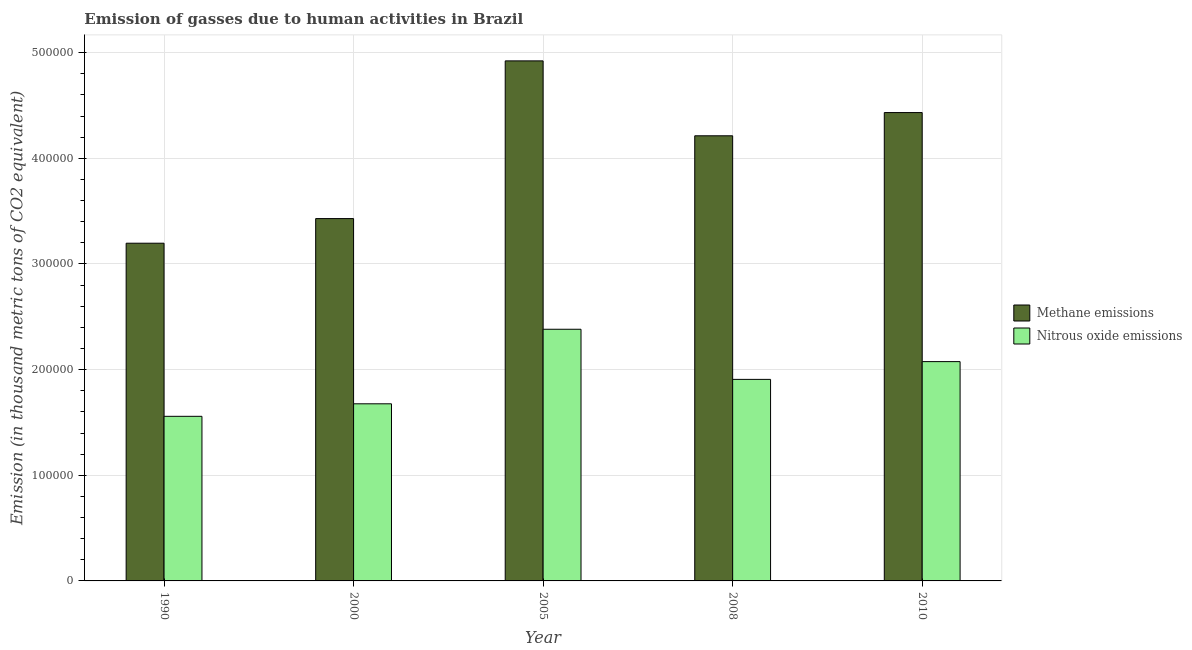How many groups of bars are there?
Your answer should be compact. 5. Are the number of bars per tick equal to the number of legend labels?
Your answer should be very brief. Yes. Are the number of bars on each tick of the X-axis equal?
Your answer should be compact. Yes. What is the amount of nitrous oxide emissions in 2005?
Your response must be concise. 2.38e+05. Across all years, what is the maximum amount of methane emissions?
Give a very brief answer. 4.92e+05. Across all years, what is the minimum amount of nitrous oxide emissions?
Your answer should be compact. 1.56e+05. In which year was the amount of methane emissions minimum?
Give a very brief answer. 1990. What is the total amount of methane emissions in the graph?
Your response must be concise. 2.02e+06. What is the difference between the amount of nitrous oxide emissions in 1990 and that in 2000?
Your answer should be very brief. -1.19e+04. What is the difference between the amount of methane emissions in 1990 and the amount of nitrous oxide emissions in 2010?
Your response must be concise. -1.24e+05. What is the average amount of nitrous oxide emissions per year?
Your response must be concise. 1.92e+05. In the year 2000, what is the difference between the amount of methane emissions and amount of nitrous oxide emissions?
Your response must be concise. 0. What is the ratio of the amount of methane emissions in 2005 to that in 2008?
Make the answer very short. 1.17. Is the amount of methane emissions in 2000 less than that in 2008?
Ensure brevity in your answer.  Yes. What is the difference between the highest and the second highest amount of nitrous oxide emissions?
Provide a succinct answer. 3.06e+04. What is the difference between the highest and the lowest amount of nitrous oxide emissions?
Offer a terse response. 8.24e+04. In how many years, is the amount of methane emissions greater than the average amount of methane emissions taken over all years?
Offer a terse response. 3. Is the sum of the amount of methane emissions in 2000 and 2010 greater than the maximum amount of nitrous oxide emissions across all years?
Ensure brevity in your answer.  Yes. What does the 2nd bar from the left in 1990 represents?
Your answer should be compact. Nitrous oxide emissions. What does the 2nd bar from the right in 2010 represents?
Keep it short and to the point. Methane emissions. Where does the legend appear in the graph?
Your answer should be very brief. Center right. How many legend labels are there?
Your response must be concise. 2. What is the title of the graph?
Offer a very short reply. Emission of gasses due to human activities in Brazil. Does "Net National savings" appear as one of the legend labels in the graph?
Give a very brief answer. No. What is the label or title of the X-axis?
Keep it short and to the point. Year. What is the label or title of the Y-axis?
Ensure brevity in your answer.  Emission (in thousand metric tons of CO2 equivalent). What is the Emission (in thousand metric tons of CO2 equivalent) in Methane emissions in 1990?
Keep it short and to the point. 3.20e+05. What is the Emission (in thousand metric tons of CO2 equivalent) in Nitrous oxide emissions in 1990?
Provide a short and direct response. 1.56e+05. What is the Emission (in thousand metric tons of CO2 equivalent) of Methane emissions in 2000?
Ensure brevity in your answer.  3.43e+05. What is the Emission (in thousand metric tons of CO2 equivalent) in Nitrous oxide emissions in 2000?
Provide a succinct answer. 1.68e+05. What is the Emission (in thousand metric tons of CO2 equivalent) of Methane emissions in 2005?
Your answer should be very brief. 4.92e+05. What is the Emission (in thousand metric tons of CO2 equivalent) of Nitrous oxide emissions in 2005?
Provide a succinct answer. 2.38e+05. What is the Emission (in thousand metric tons of CO2 equivalent) of Methane emissions in 2008?
Give a very brief answer. 4.21e+05. What is the Emission (in thousand metric tons of CO2 equivalent) in Nitrous oxide emissions in 2008?
Your response must be concise. 1.91e+05. What is the Emission (in thousand metric tons of CO2 equivalent) of Methane emissions in 2010?
Your answer should be very brief. 4.43e+05. What is the Emission (in thousand metric tons of CO2 equivalent) of Nitrous oxide emissions in 2010?
Keep it short and to the point. 2.08e+05. Across all years, what is the maximum Emission (in thousand metric tons of CO2 equivalent) of Methane emissions?
Offer a very short reply. 4.92e+05. Across all years, what is the maximum Emission (in thousand metric tons of CO2 equivalent) of Nitrous oxide emissions?
Ensure brevity in your answer.  2.38e+05. Across all years, what is the minimum Emission (in thousand metric tons of CO2 equivalent) of Methane emissions?
Your answer should be very brief. 3.20e+05. Across all years, what is the minimum Emission (in thousand metric tons of CO2 equivalent) in Nitrous oxide emissions?
Ensure brevity in your answer.  1.56e+05. What is the total Emission (in thousand metric tons of CO2 equivalent) of Methane emissions in the graph?
Ensure brevity in your answer.  2.02e+06. What is the total Emission (in thousand metric tons of CO2 equivalent) in Nitrous oxide emissions in the graph?
Offer a very short reply. 9.60e+05. What is the difference between the Emission (in thousand metric tons of CO2 equivalent) in Methane emissions in 1990 and that in 2000?
Make the answer very short. -2.33e+04. What is the difference between the Emission (in thousand metric tons of CO2 equivalent) of Nitrous oxide emissions in 1990 and that in 2000?
Your answer should be very brief. -1.19e+04. What is the difference between the Emission (in thousand metric tons of CO2 equivalent) of Methane emissions in 1990 and that in 2005?
Provide a succinct answer. -1.73e+05. What is the difference between the Emission (in thousand metric tons of CO2 equivalent) of Nitrous oxide emissions in 1990 and that in 2005?
Your response must be concise. -8.24e+04. What is the difference between the Emission (in thousand metric tons of CO2 equivalent) of Methane emissions in 1990 and that in 2008?
Ensure brevity in your answer.  -1.02e+05. What is the difference between the Emission (in thousand metric tons of CO2 equivalent) of Nitrous oxide emissions in 1990 and that in 2008?
Make the answer very short. -3.50e+04. What is the difference between the Emission (in thousand metric tons of CO2 equivalent) in Methane emissions in 1990 and that in 2010?
Your answer should be compact. -1.24e+05. What is the difference between the Emission (in thousand metric tons of CO2 equivalent) of Nitrous oxide emissions in 1990 and that in 2010?
Offer a very short reply. -5.18e+04. What is the difference between the Emission (in thousand metric tons of CO2 equivalent) of Methane emissions in 2000 and that in 2005?
Provide a succinct answer. -1.49e+05. What is the difference between the Emission (in thousand metric tons of CO2 equivalent) in Nitrous oxide emissions in 2000 and that in 2005?
Ensure brevity in your answer.  -7.06e+04. What is the difference between the Emission (in thousand metric tons of CO2 equivalent) of Methane emissions in 2000 and that in 2008?
Offer a terse response. -7.84e+04. What is the difference between the Emission (in thousand metric tons of CO2 equivalent) in Nitrous oxide emissions in 2000 and that in 2008?
Provide a short and direct response. -2.31e+04. What is the difference between the Emission (in thousand metric tons of CO2 equivalent) in Methane emissions in 2000 and that in 2010?
Offer a terse response. -1.00e+05. What is the difference between the Emission (in thousand metric tons of CO2 equivalent) of Nitrous oxide emissions in 2000 and that in 2010?
Ensure brevity in your answer.  -3.99e+04. What is the difference between the Emission (in thousand metric tons of CO2 equivalent) in Methane emissions in 2005 and that in 2008?
Your response must be concise. 7.09e+04. What is the difference between the Emission (in thousand metric tons of CO2 equivalent) of Nitrous oxide emissions in 2005 and that in 2008?
Offer a very short reply. 4.74e+04. What is the difference between the Emission (in thousand metric tons of CO2 equivalent) in Methane emissions in 2005 and that in 2010?
Give a very brief answer. 4.89e+04. What is the difference between the Emission (in thousand metric tons of CO2 equivalent) in Nitrous oxide emissions in 2005 and that in 2010?
Give a very brief answer. 3.06e+04. What is the difference between the Emission (in thousand metric tons of CO2 equivalent) in Methane emissions in 2008 and that in 2010?
Provide a short and direct response. -2.20e+04. What is the difference between the Emission (in thousand metric tons of CO2 equivalent) in Nitrous oxide emissions in 2008 and that in 2010?
Provide a succinct answer. -1.68e+04. What is the difference between the Emission (in thousand metric tons of CO2 equivalent) in Methane emissions in 1990 and the Emission (in thousand metric tons of CO2 equivalent) in Nitrous oxide emissions in 2000?
Offer a very short reply. 1.52e+05. What is the difference between the Emission (in thousand metric tons of CO2 equivalent) of Methane emissions in 1990 and the Emission (in thousand metric tons of CO2 equivalent) of Nitrous oxide emissions in 2005?
Give a very brief answer. 8.14e+04. What is the difference between the Emission (in thousand metric tons of CO2 equivalent) of Methane emissions in 1990 and the Emission (in thousand metric tons of CO2 equivalent) of Nitrous oxide emissions in 2008?
Provide a succinct answer. 1.29e+05. What is the difference between the Emission (in thousand metric tons of CO2 equivalent) of Methane emissions in 1990 and the Emission (in thousand metric tons of CO2 equivalent) of Nitrous oxide emissions in 2010?
Provide a short and direct response. 1.12e+05. What is the difference between the Emission (in thousand metric tons of CO2 equivalent) in Methane emissions in 2000 and the Emission (in thousand metric tons of CO2 equivalent) in Nitrous oxide emissions in 2005?
Provide a short and direct response. 1.05e+05. What is the difference between the Emission (in thousand metric tons of CO2 equivalent) in Methane emissions in 2000 and the Emission (in thousand metric tons of CO2 equivalent) in Nitrous oxide emissions in 2008?
Keep it short and to the point. 1.52e+05. What is the difference between the Emission (in thousand metric tons of CO2 equivalent) in Methane emissions in 2000 and the Emission (in thousand metric tons of CO2 equivalent) in Nitrous oxide emissions in 2010?
Provide a succinct answer. 1.35e+05. What is the difference between the Emission (in thousand metric tons of CO2 equivalent) of Methane emissions in 2005 and the Emission (in thousand metric tons of CO2 equivalent) of Nitrous oxide emissions in 2008?
Ensure brevity in your answer.  3.01e+05. What is the difference between the Emission (in thousand metric tons of CO2 equivalent) of Methane emissions in 2005 and the Emission (in thousand metric tons of CO2 equivalent) of Nitrous oxide emissions in 2010?
Your answer should be very brief. 2.85e+05. What is the difference between the Emission (in thousand metric tons of CO2 equivalent) of Methane emissions in 2008 and the Emission (in thousand metric tons of CO2 equivalent) of Nitrous oxide emissions in 2010?
Your response must be concise. 2.14e+05. What is the average Emission (in thousand metric tons of CO2 equivalent) in Methane emissions per year?
Your response must be concise. 4.04e+05. What is the average Emission (in thousand metric tons of CO2 equivalent) in Nitrous oxide emissions per year?
Offer a very short reply. 1.92e+05. In the year 1990, what is the difference between the Emission (in thousand metric tons of CO2 equivalent) in Methane emissions and Emission (in thousand metric tons of CO2 equivalent) in Nitrous oxide emissions?
Your answer should be compact. 1.64e+05. In the year 2000, what is the difference between the Emission (in thousand metric tons of CO2 equivalent) in Methane emissions and Emission (in thousand metric tons of CO2 equivalent) in Nitrous oxide emissions?
Make the answer very short. 1.75e+05. In the year 2005, what is the difference between the Emission (in thousand metric tons of CO2 equivalent) of Methane emissions and Emission (in thousand metric tons of CO2 equivalent) of Nitrous oxide emissions?
Your response must be concise. 2.54e+05. In the year 2008, what is the difference between the Emission (in thousand metric tons of CO2 equivalent) in Methane emissions and Emission (in thousand metric tons of CO2 equivalent) in Nitrous oxide emissions?
Offer a very short reply. 2.31e+05. In the year 2010, what is the difference between the Emission (in thousand metric tons of CO2 equivalent) of Methane emissions and Emission (in thousand metric tons of CO2 equivalent) of Nitrous oxide emissions?
Your response must be concise. 2.36e+05. What is the ratio of the Emission (in thousand metric tons of CO2 equivalent) of Methane emissions in 1990 to that in 2000?
Provide a succinct answer. 0.93. What is the ratio of the Emission (in thousand metric tons of CO2 equivalent) in Nitrous oxide emissions in 1990 to that in 2000?
Offer a very short reply. 0.93. What is the ratio of the Emission (in thousand metric tons of CO2 equivalent) of Methane emissions in 1990 to that in 2005?
Your answer should be very brief. 0.65. What is the ratio of the Emission (in thousand metric tons of CO2 equivalent) of Nitrous oxide emissions in 1990 to that in 2005?
Provide a short and direct response. 0.65. What is the ratio of the Emission (in thousand metric tons of CO2 equivalent) in Methane emissions in 1990 to that in 2008?
Provide a short and direct response. 0.76. What is the ratio of the Emission (in thousand metric tons of CO2 equivalent) in Nitrous oxide emissions in 1990 to that in 2008?
Your answer should be compact. 0.82. What is the ratio of the Emission (in thousand metric tons of CO2 equivalent) in Methane emissions in 1990 to that in 2010?
Provide a short and direct response. 0.72. What is the ratio of the Emission (in thousand metric tons of CO2 equivalent) of Nitrous oxide emissions in 1990 to that in 2010?
Provide a succinct answer. 0.75. What is the ratio of the Emission (in thousand metric tons of CO2 equivalent) of Methane emissions in 2000 to that in 2005?
Ensure brevity in your answer.  0.7. What is the ratio of the Emission (in thousand metric tons of CO2 equivalent) in Nitrous oxide emissions in 2000 to that in 2005?
Your response must be concise. 0.7. What is the ratio of the Emission (in thousand metric tons of CO2 equivalent) in Methane emissions in 2000 to that in 2008?
Give a very brief answer. 0.81. What is the ratio of the Emission (in thousand metric tons of CO2 equivalent) of Nitrous oxide emissions in 2000 to that in 2008?
Your response must be concise. 0.88. What is the ratio of the Emission (in thousand metric tons of CO2 equivalent) of Methane emissions in 2000 to that in 2010?
Keep it short and to the point. 0.77. What is the ratio of the Emission (in thousand metric tons of CO2 equivalent) of Nitrous oxide emissions in 2000 to that in 2010?
Make the answer very short. 0.81. What is the ratio of the Emission (in thousand metric tons of CO2 equivalent) in Methane emissions in 2005 to that in 2008?
Provide a short and direct response. 1.17. What is the ratio of the Emission (in thousand metric tons of CO2 equivalent) of Nitrous oxide emissions in 2005 to that in 2008?
Keep it short and to the point. 1.25. What is the ratio of the Emission (in thousand metric tons of CO2 equivalent) in Methane emissions in 2005 to that in 2010?
Provide a succinct answer. 1.11. What is the ratio of the Emission (in thousand metric tons of CO2 equivalent) in Nitrous oxide emissions in 2005 to that in 2010?
Make the answer very short. 1.15. What is the ratio of the Emission (in thousand metric tons of CO2 equivalent) in Methane emissions in 2008 to that in 2010?
Ensure brevity in your answer.  0.95. What is the ratio of the Emission (in thousand metric tons of CO2 equivalent) in Nitrous oxide emissions in 2008 to that in 2010?
Keep it short and to the point. 0.92. What is the difference between the highest and the second highest Emission (in thousand metric tons of CO2 equivalent) in Methane emissions?
Give a very brief answer. 4.89e+04. What is the difference between the highest and the second highest Emission (in thousand metric tons of CO2 equivalent) of Nitrous oxide emissions?
Offer a very short reply. 3.06e+04. What is the difference between the highest and the lowest Emission (in thousand metric tons of CO2 equivalent) of Methane emissions?
Provide a short and direct response. 1.73e+05. What is the difference between the highest and the lowest Emission (in thousand metric tons of CO2 equivalent) in Nitrous oxide emissions?
Your answer should be compact. 8.24e+04. 